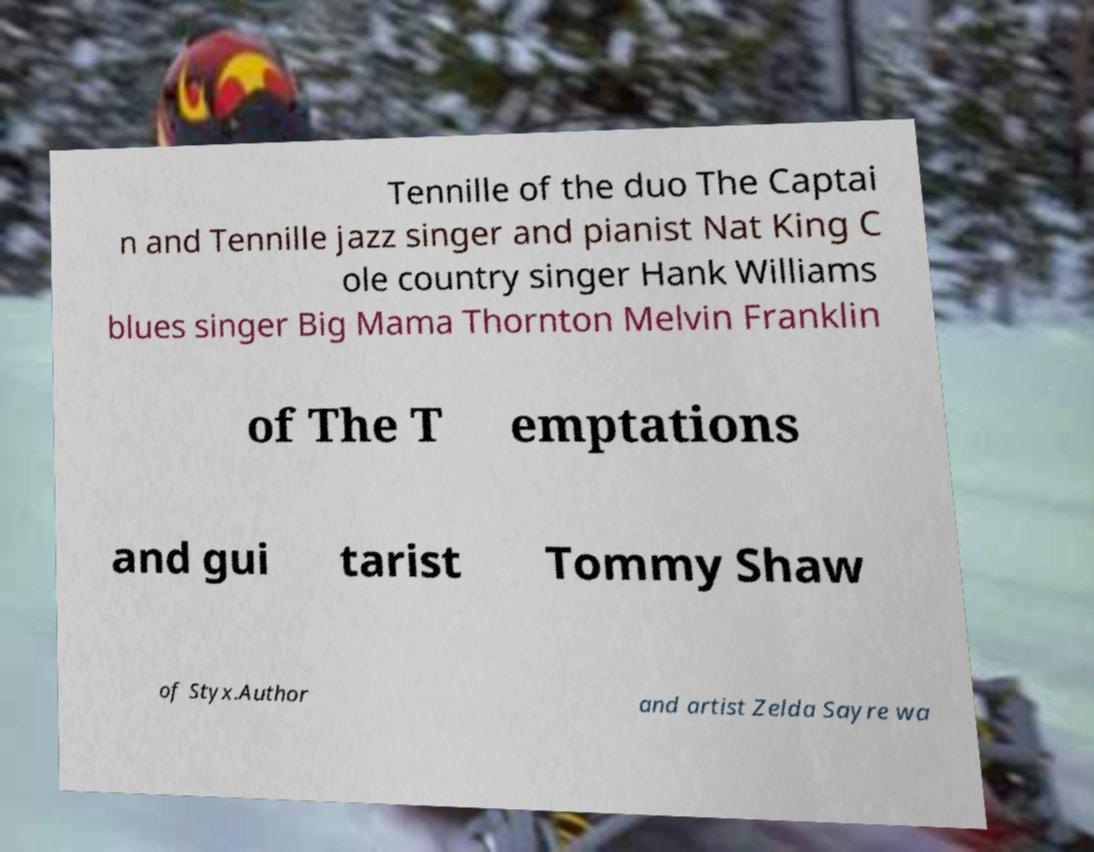Could you assist in decoding the text presented in this image and type it out clearly? Tennille of the duo The Captai n and Tennille jazz singer and pianist Nat King C ole country singer Hank Williams blues singer Big Mama Thornton Melvin Franklin of The T emptations and gui tarist Tommy Shaw of Styx.Author and artist Zelda Sayre wa 